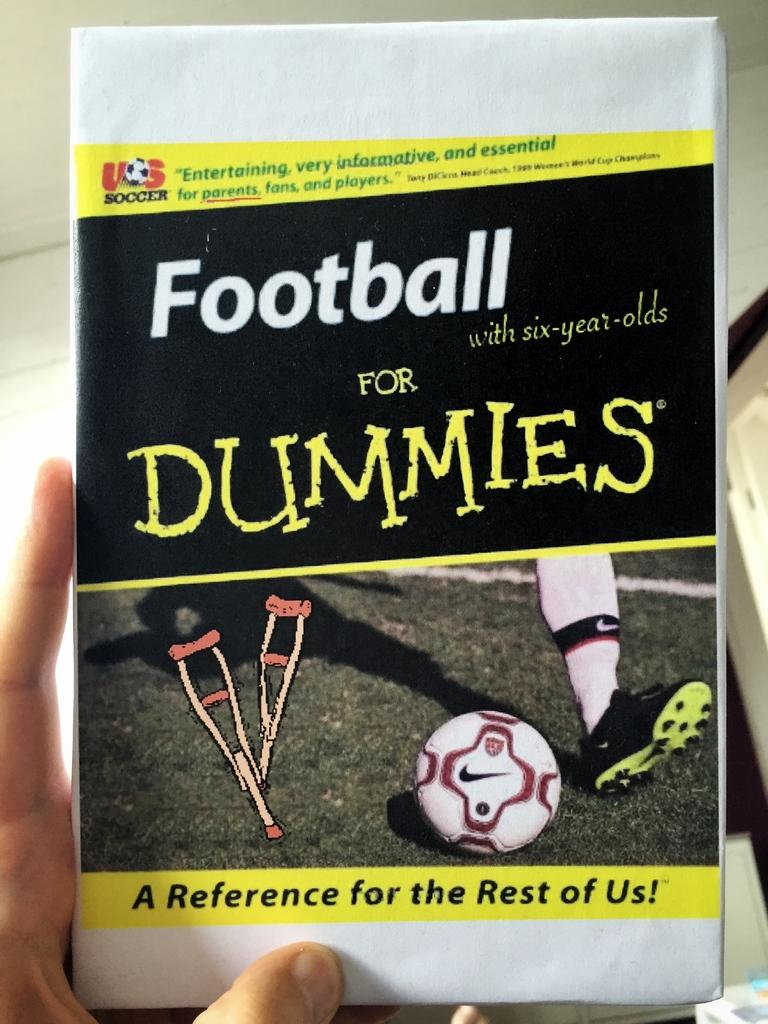Provide a one-sentence caption for the provided image. A close up of a hand holding a book with the name "Football for Dummies". 